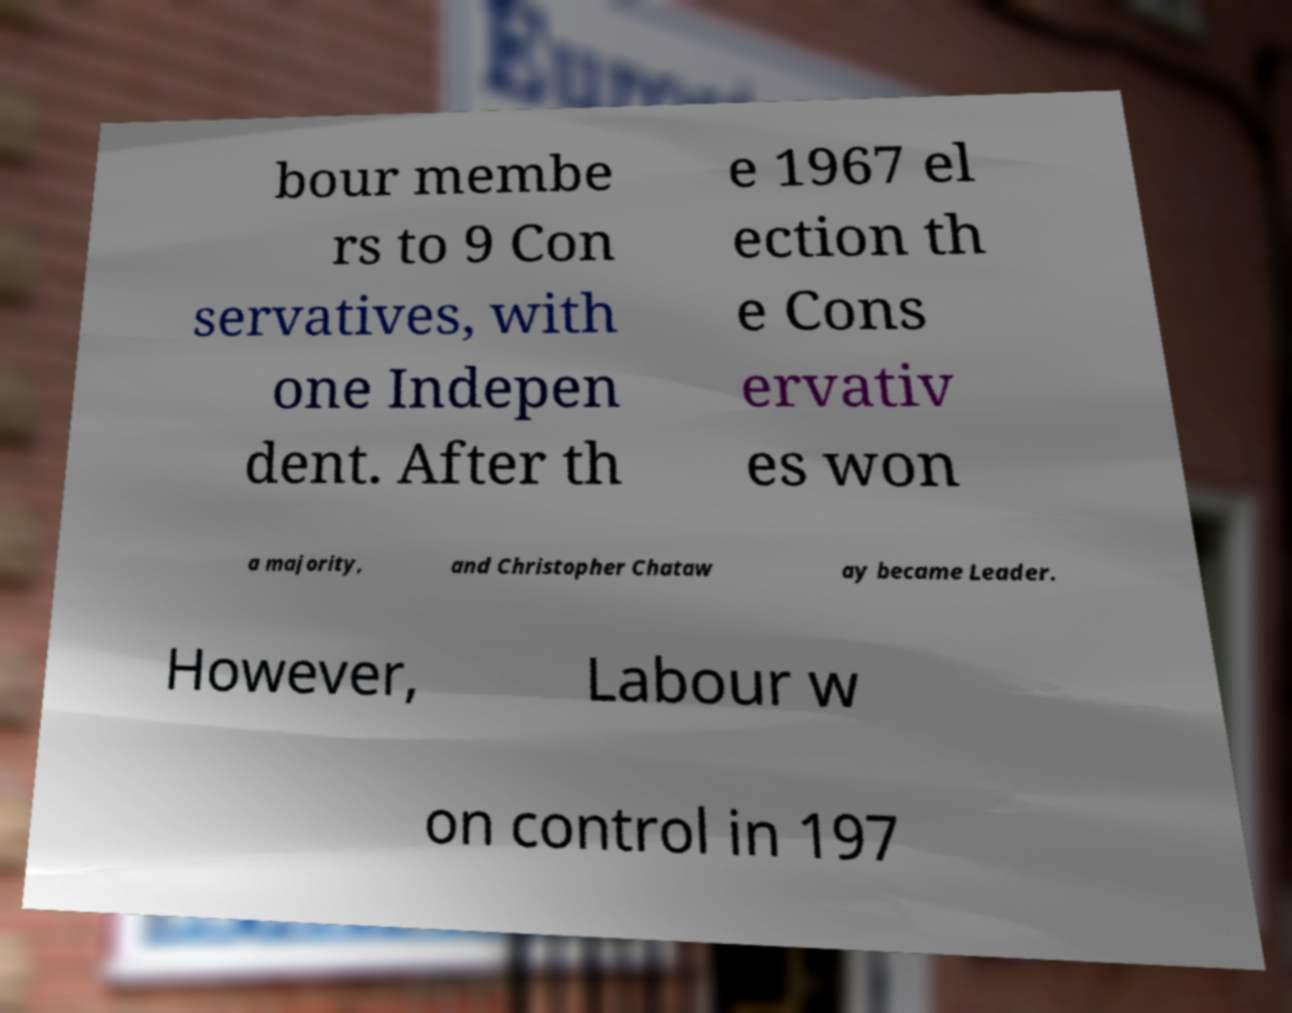What messages or text are displayed in this image? I need them in a readable, typed format. bour membe rs to 9 Con servatives, with one Indepen dent. After th e 1967 el ection th e Cons ervativ es won a majority, and Christopher Chataw ay became Leader. However, Labour w on control in 197 